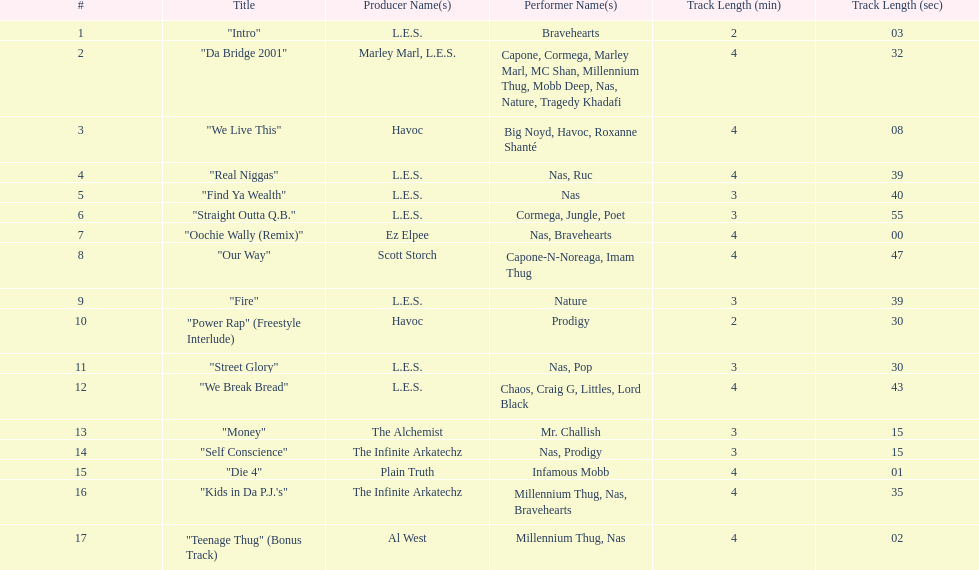What are all the song titles? "Intro", "Da Bridge 2001", "We Live This", "Real Niggas", "Find Ya Wealth", "Straight Outta Q.B.", "Oochie Wally (Remix)", "Our Way", "Fire", "Power Rap" (Freestyle Interlude), "Street Glory", "We Break Bread", "Money", "Self Conscience", "Die 4", "Kids in Da P.J.'s", "Teenage Thug" (Bonus Track). Who produced all these songs? L.E.S., Marley Marl, L.E.S., Ez Elpee, Scott Storch, Havoc, The Alchemist, The Infinite Arkatechz, Plain Truth, Al West. Of the producers, who produced the shortest song? L.E.S. How short was this producer's song? 2:03. 